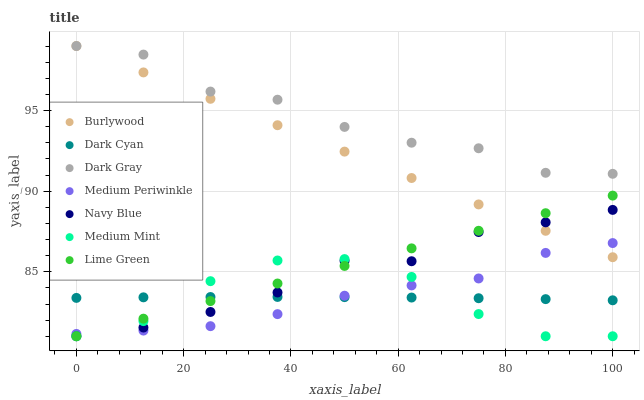Does Medium Mint have the minimum area under the curve?
Answer yes or no. Yes. Does Dark Gray have the maximum area under the curve?
Answer yes or no. Yes. Does Burlywood have the minimum area under the curve?
Answer yes or no. No. Does Burlywood have the maximum area under the curve?
Answer yes or no. No. Is Burlywood the smoothest?
Answer yes or no. Yes. Is Dark Gray the roughest?
Answer yes or no. Yes. Is Navy Blue the smoothest?
Answer yes or no. No. Is Navy Blue the roughest?
Answer yes or no. No. Does Medium Mint have the lowest value?
Answer yes or no. Yes. Does Burlywood have the lowest value?
Answer yes or no. No. Does Dark Gray have the highest value?
Answer yes or no. Yes. Does Navy Blue have the highest value?
Answer yes or no. No. Is Medium Mint less than Burlywood?
Answer yes or no. Yes. Is Dark Gray greater than Dark Cyan?
Answer yes or no. Yes. Does Medium Periwinkle intersect Burlywood?
Answer yes or no. Yes. Is Medium Periwinkle less than Burlywood?
Answer yes or no. No. Is Medium Periwinkle greater than Burlywood?
Answer yes or no. No. Does Medium Mint intersect Burlywood?
Answer yes or no. No. 